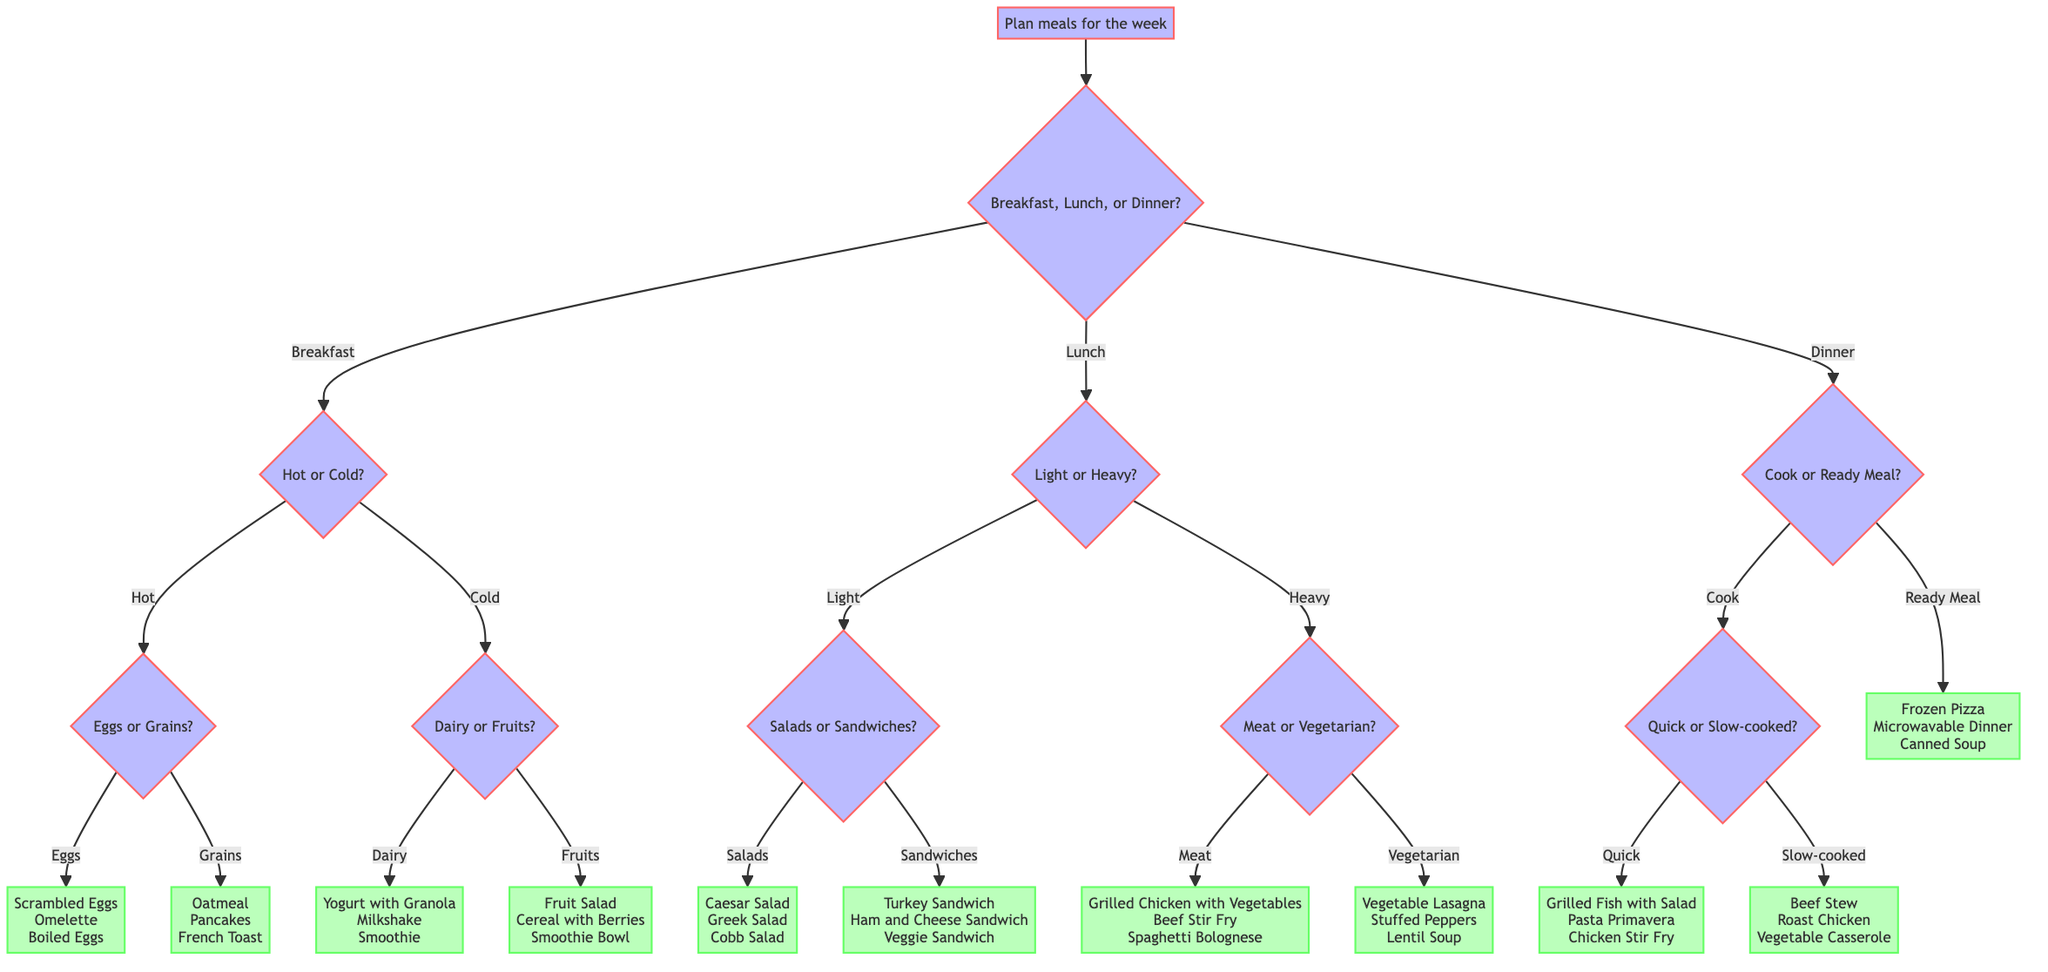What are the main meal categories in this diagram? The diagram starts with a main question that branches into three categories: Breakfast, Lunch, and Dinner. Therefore, the main meal categories depicted are the three types of meals.
Answer: Breakfast, Lunch, Dinner What is the first decision to make when planning meals? The first decision is to choose between the meal categories of Breakfast, Lunch, or Dinner. This is indicated as the first question that branches out from the goal of planning meals.
Answer: Breakfast, Lunch, or Dinner How many options are offered for hot breakfasts? After selecting "Breakfast," if "Hot" is chosen, the next question asks whether to choose "Eggs" or "Grains." The "Eggs" option leads to three answer choices: Scrambled Eggs, Omelette, and Boiled Eggs. Thus, there are three options for hot breakfasts.
Answer: 3 What meal option is provided if a person chooses a ready meal for dinner? If "Dinner" is chosen and "Ready Meal" is selected as the preference, the diagram directly provides three answer options: Frozen Pizza, Microwavable Dinner, and Canned Soup. This reflects what is available under the ready meal category for dinner.
Answer: Frozen Pizza, Microwavable Dinner, Canned Soup If a person prefers vegetarian options for lunch, what are their meal choices? Upon selecting "Lunch" and then "Heavy," the next decision is between "Meat" or "Vegetarian." Choosing "Vegetarian" leads to three meal options: Vegetable Lasagna, Stuffed Peppers, and Lentil Soup. This sequence combines the decisions to reach vegetarian choices.
Answer: Vegetable Lasagna, Stuffed Peppers, Lentil Soup What types of breakfast can one choose if they prefer cold meals? Choosing "Breakfast" followed by "Cold" leads to a decision between "Dairy" or "Fruits." Selecting "Dairy" leads to three breakfast options: Yogurt with Granola, Milkshake, and Smoothie; while "Fruits" leads to Fruit Salad, Cereal with Berries, and Smoothie Bowl. This combines the cold breakfast decision with both dairy and fruit options.
Answer: Yogurt with Granola, Milkshake, Smoothie, Fruit Salad, Cereal with Berries, Smoothie Bowl What are the meal options if a person wants to cook a quick dinner? If "Dinner" is selected and the decision for "Cook" is made, the next question is between "Quick" or "Slow-cooked." Choosing "Quick" leads to the options: Grilled Fish with Salad, Pasta Primavera, and Chicken Stir Fry. This follows the path of preferring to cook and selecting a quick option.
Answer: Grilled Fish with Salad, Pasta Primavera, Chicken Stir Fry How many total options are available under lunch if light meals are preferred? Upon the choice of "Lunch" and "Light," the next decision point offers two categories: "Salads" or "Sandwiches." When selecting "Salads," there are three options: Caesar Salad, Greek Salad, and Cobb Salad. If "Sandwiches" is chosen, there are also three options: Turkey Sandwich, Ham and Cheese Sandwich, and Veggie Sandwich. Combining these gives a total of six lunch options under the light category.
Answer: 6 